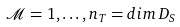Convert formula to latex. <formula><loc_0><loc_0><loc_500><loc_500>\mathcal { M } = 1 , \dots , n _ { T } = d i m \, D _ { S }</formula> 